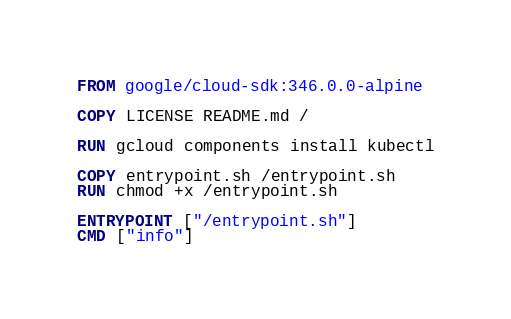Convert code to text. <code><loc_0><loc_0><loc_500><loc_500><_Dockerfile_>FROM google/cloud-sdk:346.0.0-alpine

COPY LICENSE README.md /

RUN gcloud components install kubectl

COPY entrypoint.sh /entrypoint.sh
RUN chmod +x /entrypoint.sh

ENTRYPOINT ["/entrypoint.sh"]
CMD ["info"]
</code> 